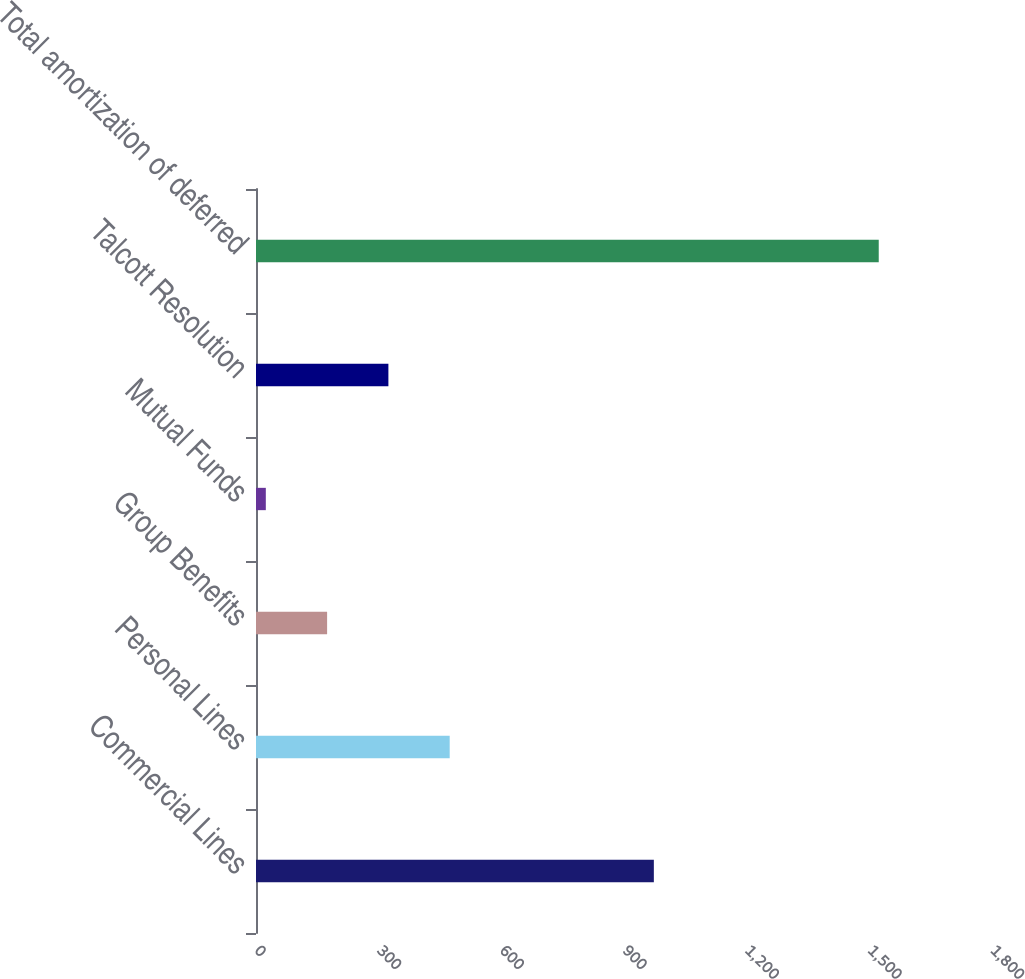<chart> <loc_0><loc_0><loc_500><loc_500><bar_chart><fcel>Commercial Lines<fcel>Personal Lines<fcel>Group Benefits<fcel>Mutual Funds<fcel>Talcott Resolution<fcel>Total amortization of deferred<nl><fcel>973<fcel>473.7<fcel>173.9<fcel>24<fcel>323.8<fcel>1523<nl></chart> 